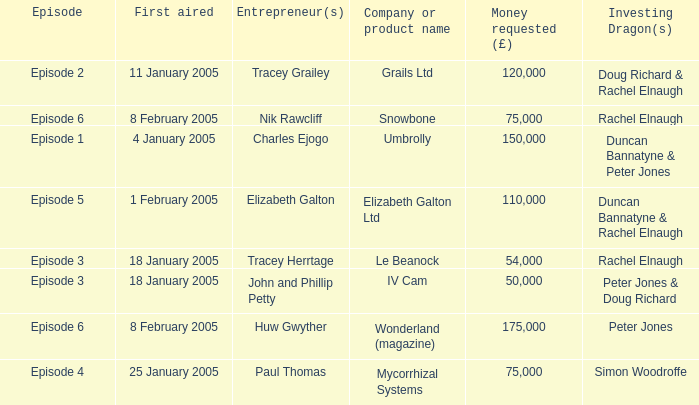Who were the Investing Dragons in the episode that first aired on 18 January 2005 with the entrepreneur Tracey Herrtage? Rachel Elnaugh. 